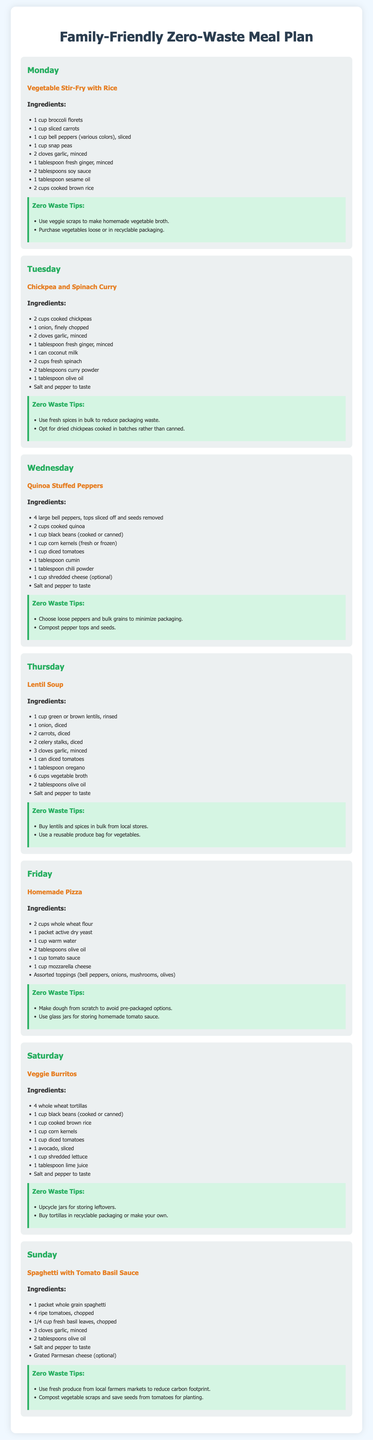What is the dinner for Monday? The dinner for Monday is specified in the Meal plan section as "Vegetable Stir-Fry with Rice."
Answer: Vegetable Stir-Fry with Rice How many cups of cooked chickpeas are needed for Tuesday's meal? For Tuesday's meal, the ingredients list shows "2 cups cooked chickpeas" are required.
Answer: 2 cups What type of oil is used in the Quinoa Stuffed Peppers? The ingredient list for Quinoa Stuffed Peppers includes "1 cup shredded cheese (optional)" and "1 tablespoon cumin" but does not specify oil; it's not used in this particular dish.
Answer: No oil used Which ingredient is optional in the Friday meal? For the Friday meal, "1 cup shredded cheese (optional)" indicates that cheese is not mandatory.
Answer: shredded cheese What is one zero waste tip for Lentil Soup? The section under "Zero Waste Tips" suggests "Buy lentils and spices in bulk from local stores."
Answer: Buy lentils in bulk What ingredient do you need to make Veggie Burritos? The meal plan requires "4 whole wheat tortillas" as a main ingredient for Veggie Burritos.
Answer: 4 whole wheat tortillas How many cups of vegetable broth are used in the Lentil Soup? The Lentil Soup recipe specifies "6 cups vegetable broth" in the ingredients list.
Answer: 6 cups What is a zero waste tip for Homemade Pizza? The tip given for Homemade Pizza is to "Make dough from scratch to avoid pre-packaged options."
Answer: Make dough from scratch How many large bell peppers are needed for Wednesday's meal? The meal plan states that "4 large bell peppers" are needed for the Quinoa Stuffed Peppers.
Answer: 4 large bell peppers 